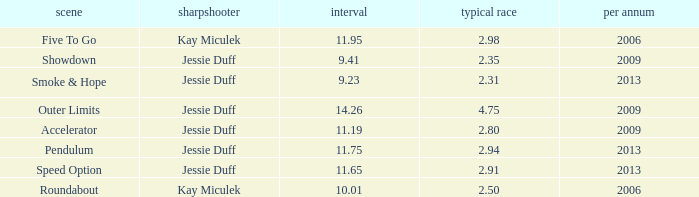What is the total years with average runs less than 4.75 and a time of 14.26? 0.0. 